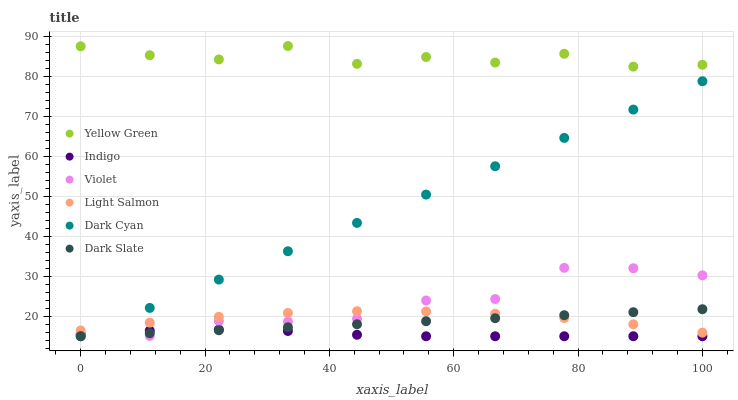Does Indigo have the minimum area under the curve?
Answer yes or no. Yes. Does Yellow Green have the maximum area under the curve?
Answer yes or no. Yes. Does Yellow Green have the minimum area under the curve?
Answer yes or no. No. Does Indigo have the maximum area under the curve?
Answer yes or no. No. Is Dark Slate the smoothest?
Answer yes or no. Yes. Is Yellow Green the roughest?
Answer yes or no. Yes. Is Indigo the smoothest?
Answer yes or no. No. Is Indigo the roughest?
Answer yes or no. No. Does Indigo have the lowest value?
Answer yes or no. Yes. Does Yellow Green have the lowest value?
Answer yes or no. No. Does Yellow Green have the highest value?
Answer yes or no. Yes. Does Indigo have the highest value?
Answer yes or no. No. Is Dark Slate less than Yellow Green?
Answer yes or no. Yes. Is Yellow Green greater than Light Salmon?
Answer yes or no. Yes. Does Indigo intersect Violet?
Answer yes or no. Yes. Is Indigo less than Violet?
Answer yes or no. No. Is Indigo greater than Violet?
Answer yes or no. No. Does Dark Slate intersect Yellow Green?
Answer yes or no. No. 